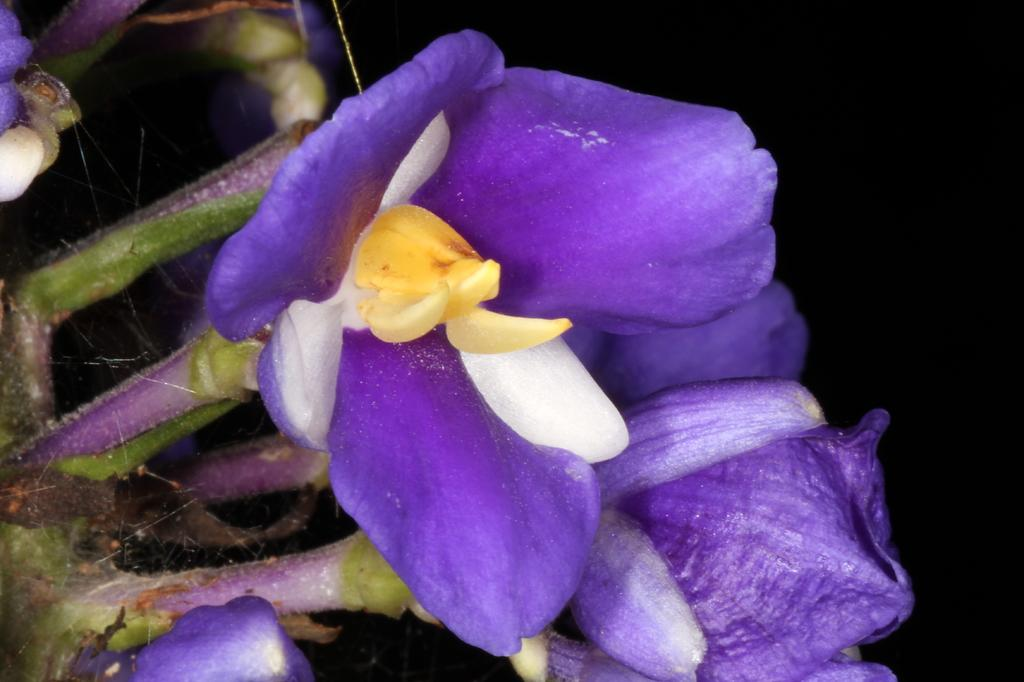What is located in the foreground of the image? There are flowers in the foreground of the image. What color is the background of the image? The background of the image is black. Are there any balloons visible in the image? There are no balloons present in the image. Can you see any servants in the image? There is no reference to a servant in the image. How many beads are scattered around the flowers in the image? There is no mention of beads in the image, so it is not possible to determine how many might be present. 